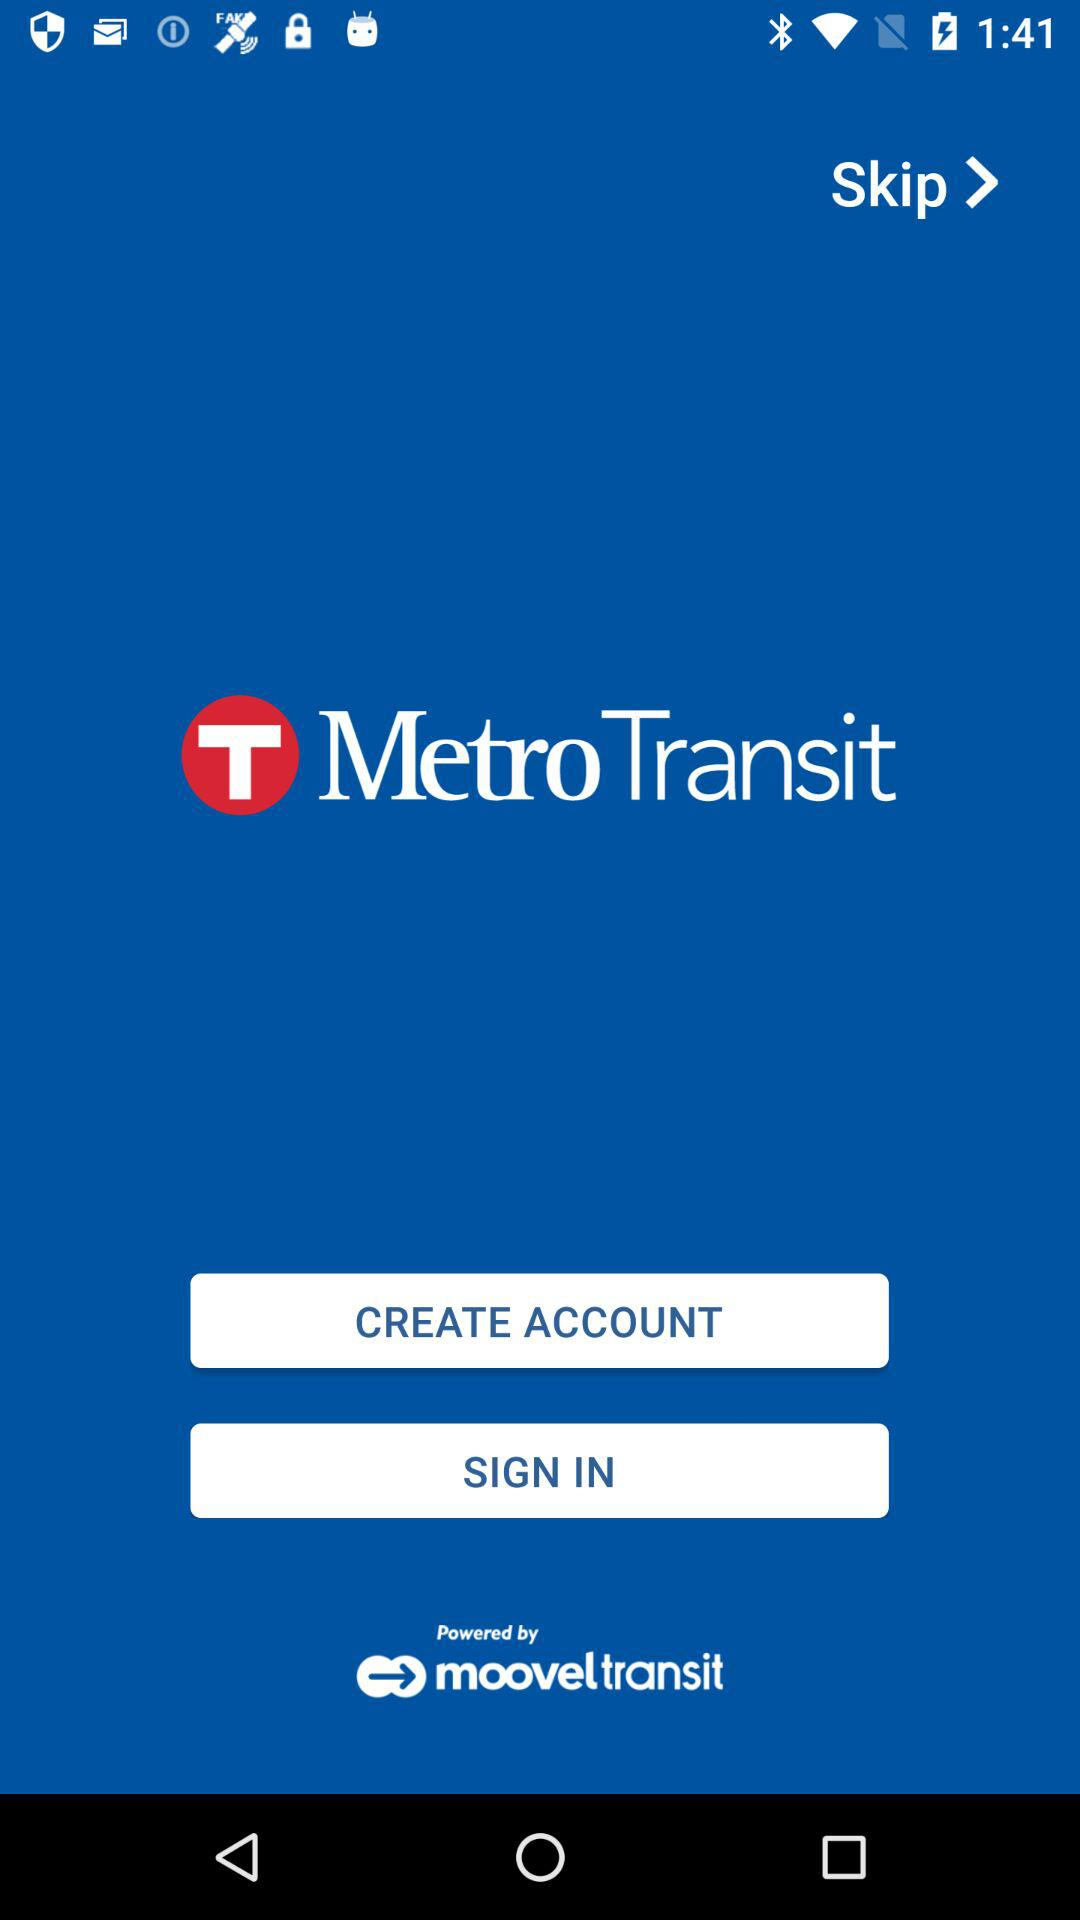What is the name of the application? The name of the application is "Metro Transit". 